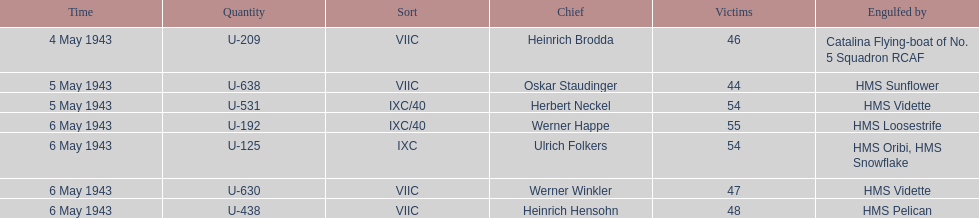Which ship sunk the most u-boats HMS Vidette. 